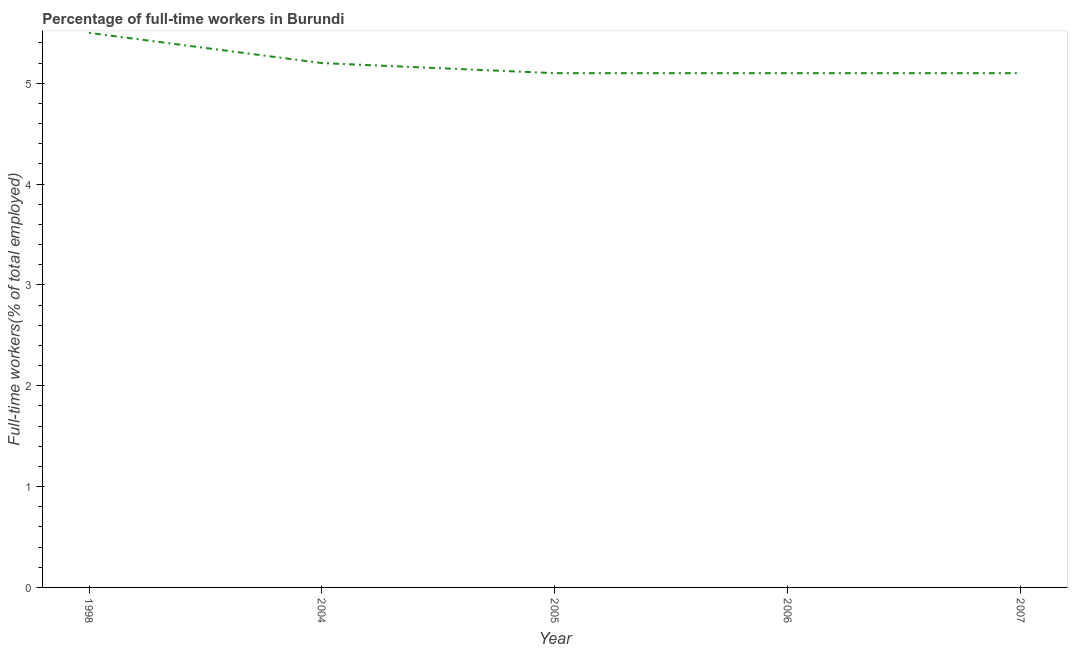What is the percentage of full-time workers in 2004?
Your answer should be very brief. 5.2. Across all years, what is the maximum percentage of full-time workers?
Your answer should be very brief. 5.5. Across all years, what is the minimum percentage of full-time workers?
Your answer should be very brief. 5.1. In which year was the percentage of full-time workers maximum?
Keep it short and to the point. 1998. In which year was the percentage of full-time workers minimum?
Your answer should be very brief. 2005. What is the sum of the percentage of full-time workers?
Offer a very short reply. 26. What is the difference between the percentage of full-time workers in 2004 and 2005?
Offer a very short reply. 0.1. What is the average percentage of full-time workers per year?
Offer a very short reply. 5.2. What is the median percentage of full-time workers?
Offer a very short reply. 5.1. What is the ratio of the percentage of full-time workers in 2004 to that in 2007?
Offer a terse response. 1.02. Is the percentage of full-time workers in 2004 less than that in 2006?
Make the answer very short. No. Is the difference between the percentage of full-time workers in 2005 and 2007 greater than the difference between any two years?
Keep it short and to the point. No. What is the difference between the highest and the second highest percentage of full-time workers?
Give a very brief answer. 0.3. What is the difference between the highest and the lowest percentage of full-time workers?
Keep it short and to the point. 0.4. Does the percentage of full-time workers monotonically increase over the years?
Make the answer very short. No. How many years are there in the graph?
Your answer should be compact. 5. What is the difference between two consecutive major ticks on the Y-axis?
Your answer should be compact. 1. Does the graph contain grids?
Your answer should be very brief. No. What is the title of the graph?
Offer a very short reply. Percentage of full-time workers in Burundi. What is the label or title of the X-axis?
Your answer should be very brief. Year. What is the label or title of the Y-axis?
Your response must be concise. Full-time workers(% of total employed). What is the Full-time workers(% of total employed) of 1998?
Your response must be concise. 5.5. What is the Full-time workers(% of total employed) of 2004?
Offer a terse response. 5.2. What is the Full-time workers(% of total employed) of 2005?
Provide a succinct answer. 5.1. What is the Full-time workers(% of total employed) of 2006?
Provide a short and direct response. 5.1. What is the Full-time workers(% of total employed) of 2007?
Give a very brief answer. 5.1. What is the difference between the Full-time workers(% of total employed) in 1998 and 2004?
Make the answer very short. 0.3. What is the difference between the Full-time workers(% of total employed) in 1998 and 2005?
Provide a succinct answer. 0.4. What is the difference between the Full-time workers(% of total employed) in 1998 and 2006?
Your answer should be very brief. 0.4. What is the difference between the Full-time workers(% of total employed) in 1998 and 2007?
Offer a terse response. 0.4. What is the difference between the Full-time workers(% of total employed) in 2004 and 2005?
Provide a succinct answer. 0.1. What is the difference between the Full-time workers(% of total employed) in 2005 and 2006?
Make the answer very short. 0. What is the ratio of the Full-time workers(% of total employed) in 1998 to that in 2004?
Ensure brevity in your answer.  1.06. What is the ratio of the Full-time workers(% of total employed) in 1998 to that in 2005?
Your response must be concise. 1.08. What is the ratio of the Full-time workers(% of total employed) in 1998 to that in 2006?
Provide a succinct answer. 1.08. What is the ratio of the Full-time workers(% of total employed) in 1998 to that in 2007?
Provide a short and direct response. 1.08. What is the ratio of the Full-time workers(% of total employed) in 2004 to that in 2005?
Offer a very short reply. 1.02. What is the ratio of the Full-time workers(% of total employed) in 2005 to that in 2007?
Give a very brief answer. 1. 